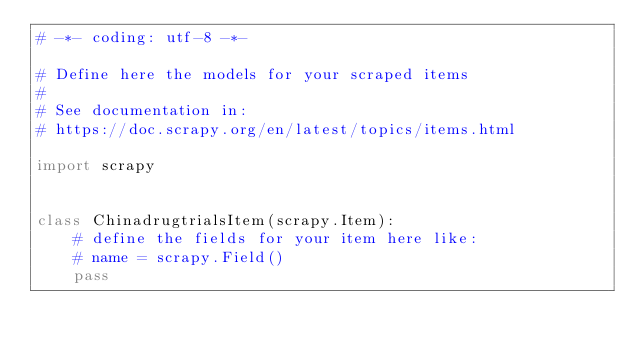<code> <loc_0><loc_0><loc_500><loc_500><_Python_># -*- coding: utf-8 -*-

# Define here the models for your scraped items
#
# See documentation in:
# https://doc.scrapy.org/en/latest/topics/items.html

import scrapy


class ChinadrugtrialsItem(scrapy.Item):
    # define the fields for your item here like:
    # name = scrapy.Field()
    pass
</code> 